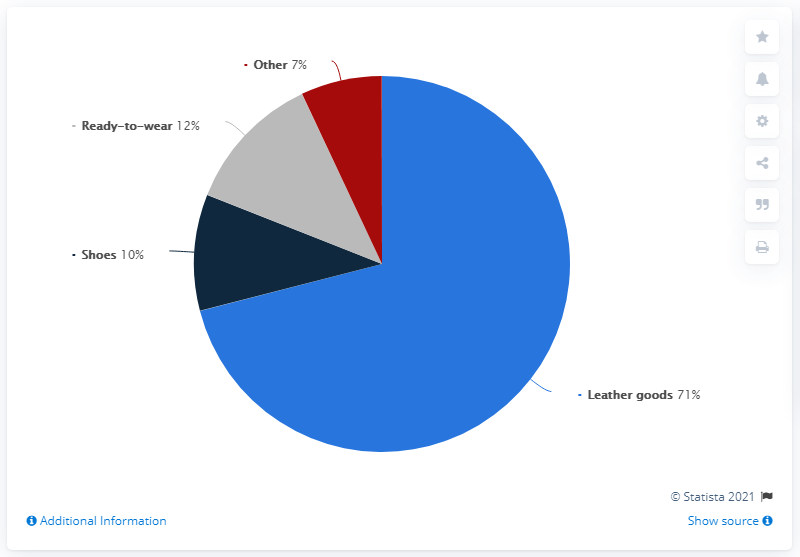Indicate a few pertinent items in this graphic. Saint Laurent had the highest global revenue share of all products in 2020, primarily from its leather goods. The global revenue share of shoes and ready-to-wear products is not provided. 